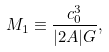Convert formula to latex. <formula><loc_0><loc_0><loc_500><loc_500>M _ { 1 } \equiv \frac { c _ { 0 } ^ { 3 } } { | 2 A | G } ,</formula> 